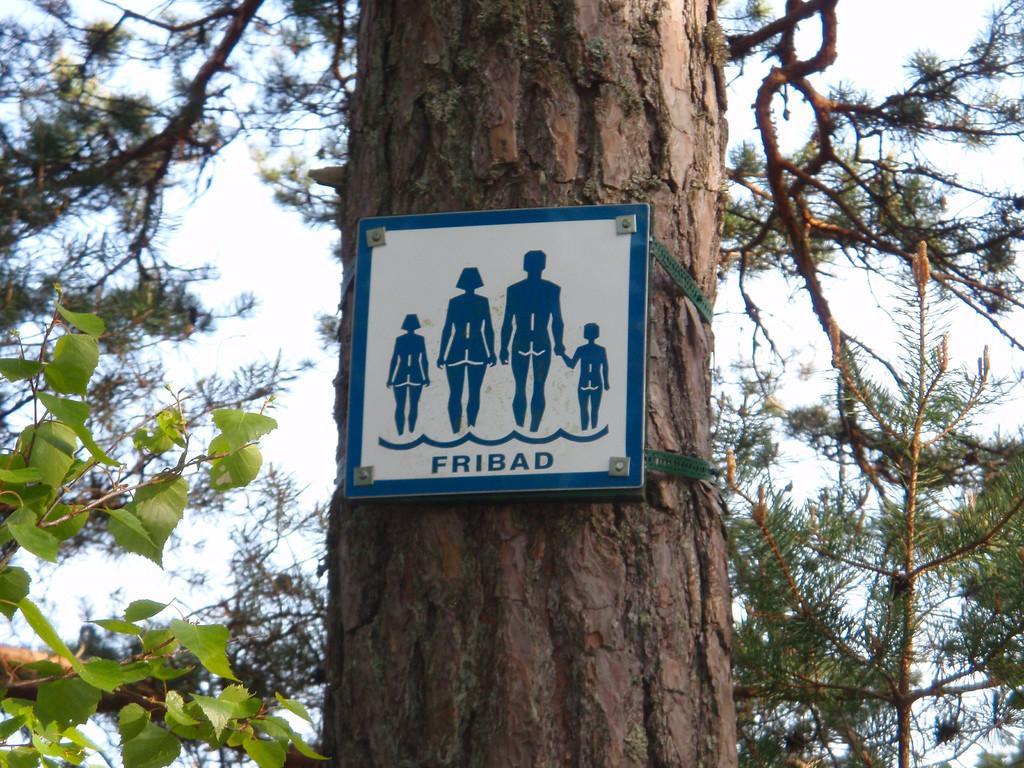Please provide a concise description of this image. In this image, in the middle we can see a tree trunk and we can see a board on the tree trunk. On the left side, we can see some green leaves and we can see the sky. 